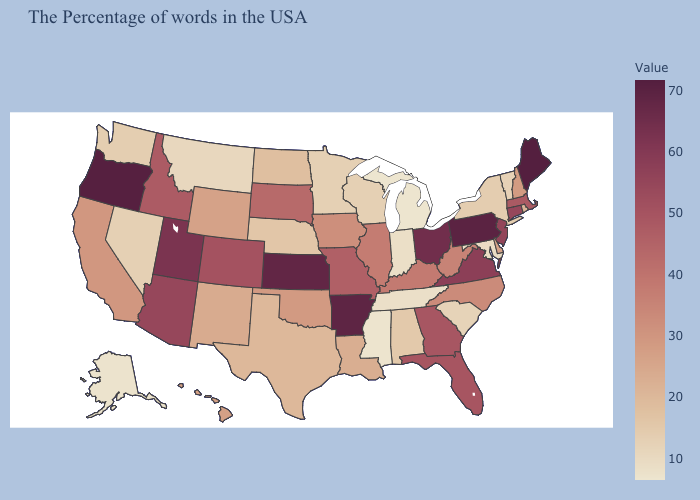Which states hav the highest value in the South?
Write a very short answer. Arkansas. Does Massachusetts have the highest value in the Northeast?
Give a very brief answer. No. Does Kansas have a higher value than Iowa?
Give a very brief answer. Yes. 